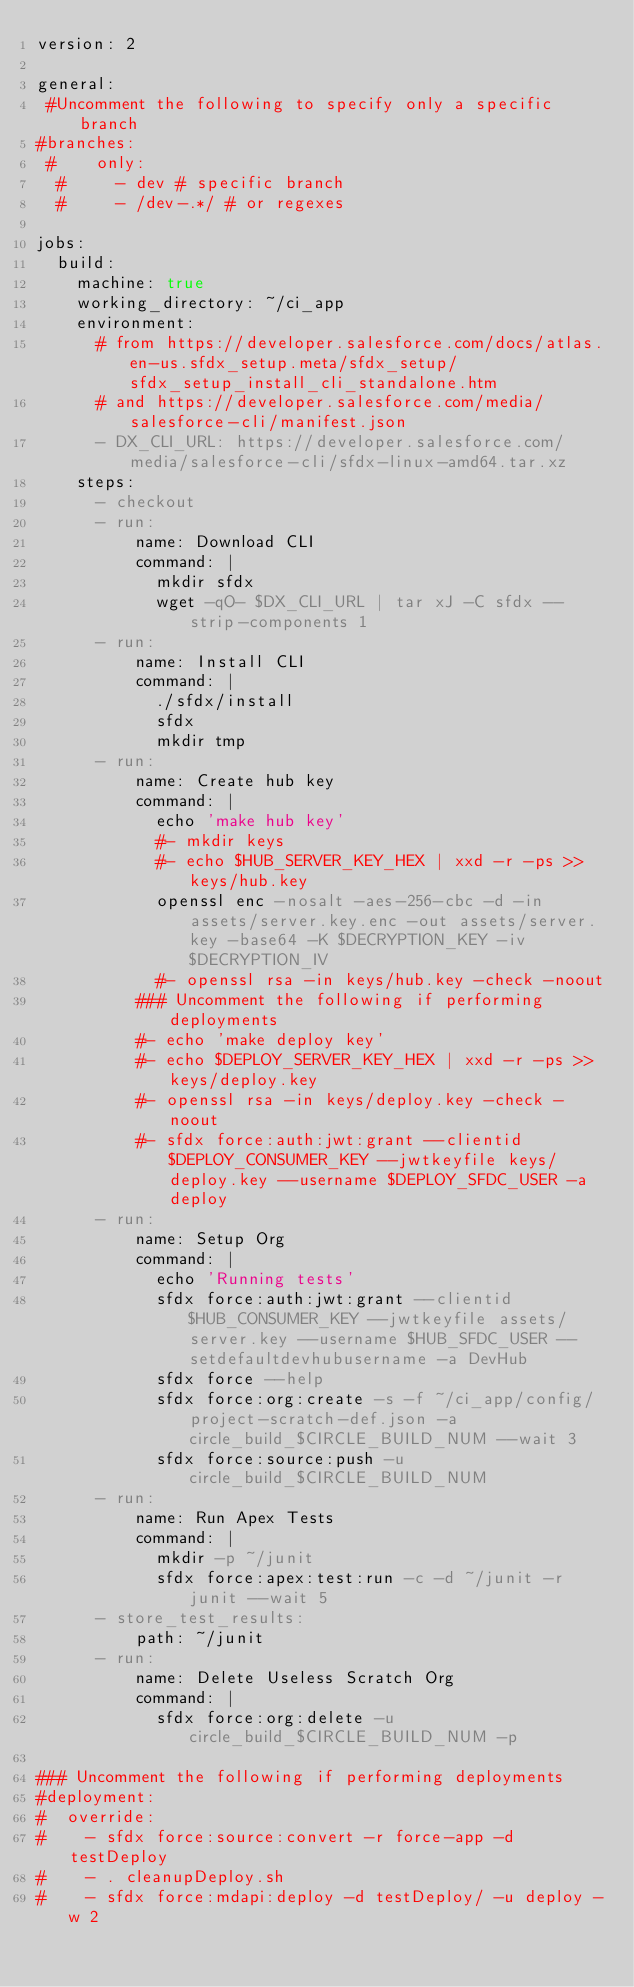Convert code to text. <code><loc_0><loc_0><loc_500><loc_500><_YAML_>version: 2

general:
 #Uncomment the following to specify only a specific branch
#branches:
 #    only:
  #     - dev # specific branch
  #     - /dev-.*/ # or regexes

jobs:
  build:
    machine: true
    working_directory: ~/ci_app
    environment:
      # from https://developer.salesforce.com/docs/atlas.en-us.sfdx_setup.meta/sfdx_setup/sfdx_setup_install_cli_standalone.htm
      # and https://developer.salesforce.com/media/salesforce-cli/manifest.json
      - DX_CLI_URL: https://developer.salesforce.com/media/salesforce-cli/sfdx-linux-amd64.tar.xz
    steps:
      - checkout
      - run:
          name: Download CLI
          command: |
            mkdir sfdx
            wget -qO- $DX_CLI_URL | tar xJ -C sfdx --strip-components 1
      - run:
          name: Install CLI
          command: |
            ./sfdx/install
            sfdx
            mkdir tmp
      - run:
          name: Create hub key
          command: |
            echo 'make hub key'
            #- mkdir keys
            #- echo $HUB_SERVER_KEY_HEX | xxd -r -ps >> keys/hub.key
            openssl enc -nosalt -aes-256-cbc -d -in assets/server.key.enc -out assets/server.key -base64 -K $DECRYPTION_KEY -iv $DECRYPTION_IV
            #- openssl rsa -in keys/hub.key -check -noout
          ### Uncomment the following if performing deployments
          #- echo 'make deploy key'
          #- echo $DEPLOY_SERVER_KEY_HEX | xxd -r -ps >> keys/deploy.key
          #- openssl rsa -in keys/deploy.key -check -noout
          #- sfdx force:auth:jwt:grant --clientid $DEPLOY_CONSUMER_KEY --jwtkeyfile keys/deploy.key --username $DEPLOY_SFDC_USER -a deploy
      - run:
          name: Setup Org
          command: |
            echo 'Running tests'
            sfdx force:auth:jwt:grant --clientid $HUB_CONSUMER_KEY --jwtkeyfile assets/server.key --username $HUB_SFDC_USER --setdefaultdevhubusername -a DevHub
            sfdx force --help
            sfdx force:org:create -s -f ~/ci_app/config/project-scratch-def.json -a circle_build_$CIRCLE_BUILD_NUM --wait 3
            sfdx force:source:push -u circle_build_$CIRCLE_BUILD_NUM
      - run:
          name: Run Apex Tests
          command: |
            mkdir -p ~/junit
            sfdx force:apex:test:run -c -d ~/junit -r junit --wait 5
      - store_test_results:
          path: ~/junit
      - run:
          name: Delete Useless Scratch Org
          command: |
            sfdx force:org:delete -u circle_build_$CIRCLE_BUILD_NUM -p

### Uncomment the following if performing deployments
#deployment:
#  override:
#    - sfdx force:source:convert -r force-app -d testDeploy
#    - . cleanupDeploy.sh
#    - sfdx force:mdapi:deploy -d testDeploy/ -u deploy -w 2
</code> 